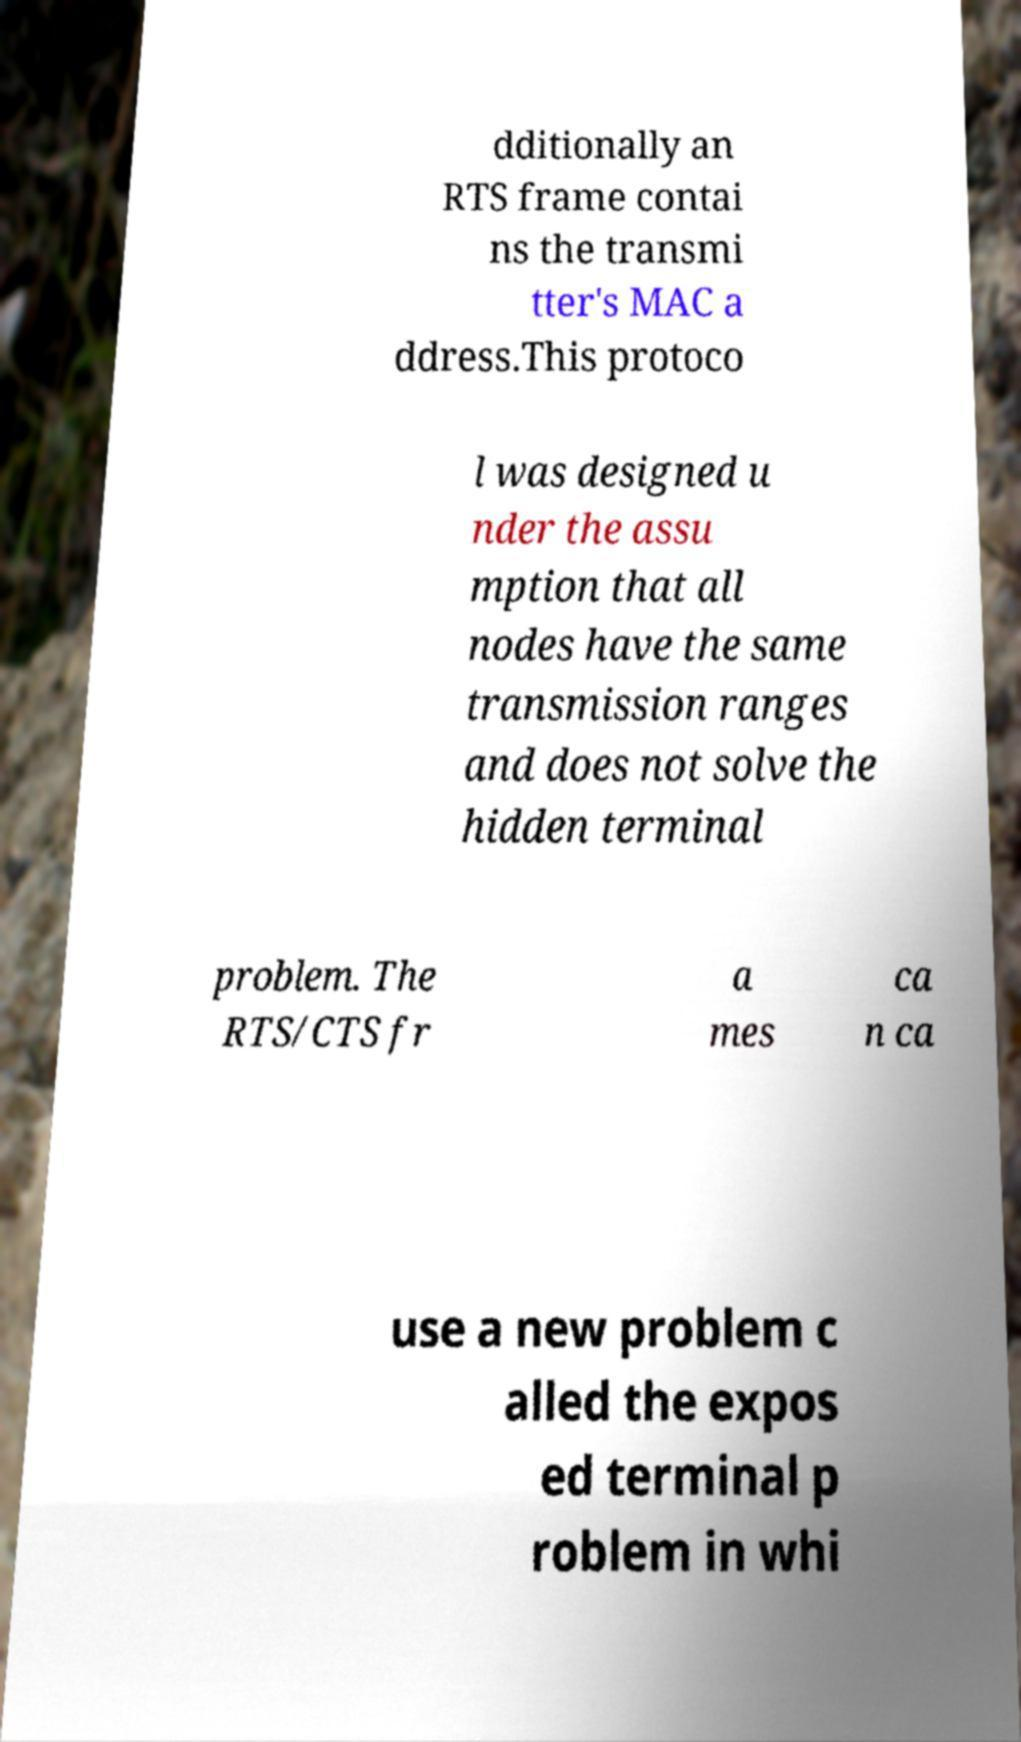Could you assist in decoding the text presented in this image and type it out clearly? dditionally an RTS frame contai ns the transmi tter's MAC a ddress.This protoco l was designed u nder the assu mption that all nodes have the same transmission ranges and does not solve the hidden terminal problem. The RTS/CTS fr a mes ca n ca use a new problem c alled the expos ed terminal p roblem in whi 